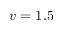Convert formula to latex. <formula><loc_0><loc_0><loc_500><loc_500>v = 1 . 5</formula> 